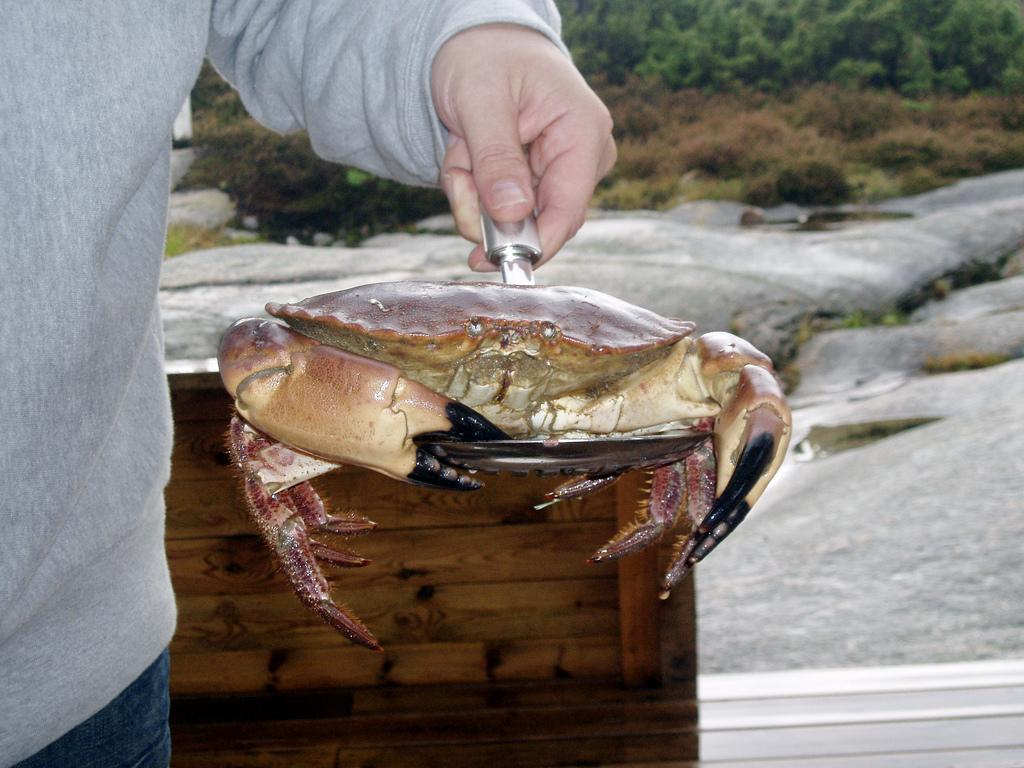Who or what is the main subject in the image? There is a person in the image. What is the person holding in the image? The person is holding a crab. Can you describe the wooden object behind the person? There is a wooden object behind the person. What type of natural elements can be seen in the image? There are rocks, plants, and trees visible in the image. What type of shoes is the person wearing in the image? There is no information about the person's shoes in the provided facts, so it cannot be determined from the image. 